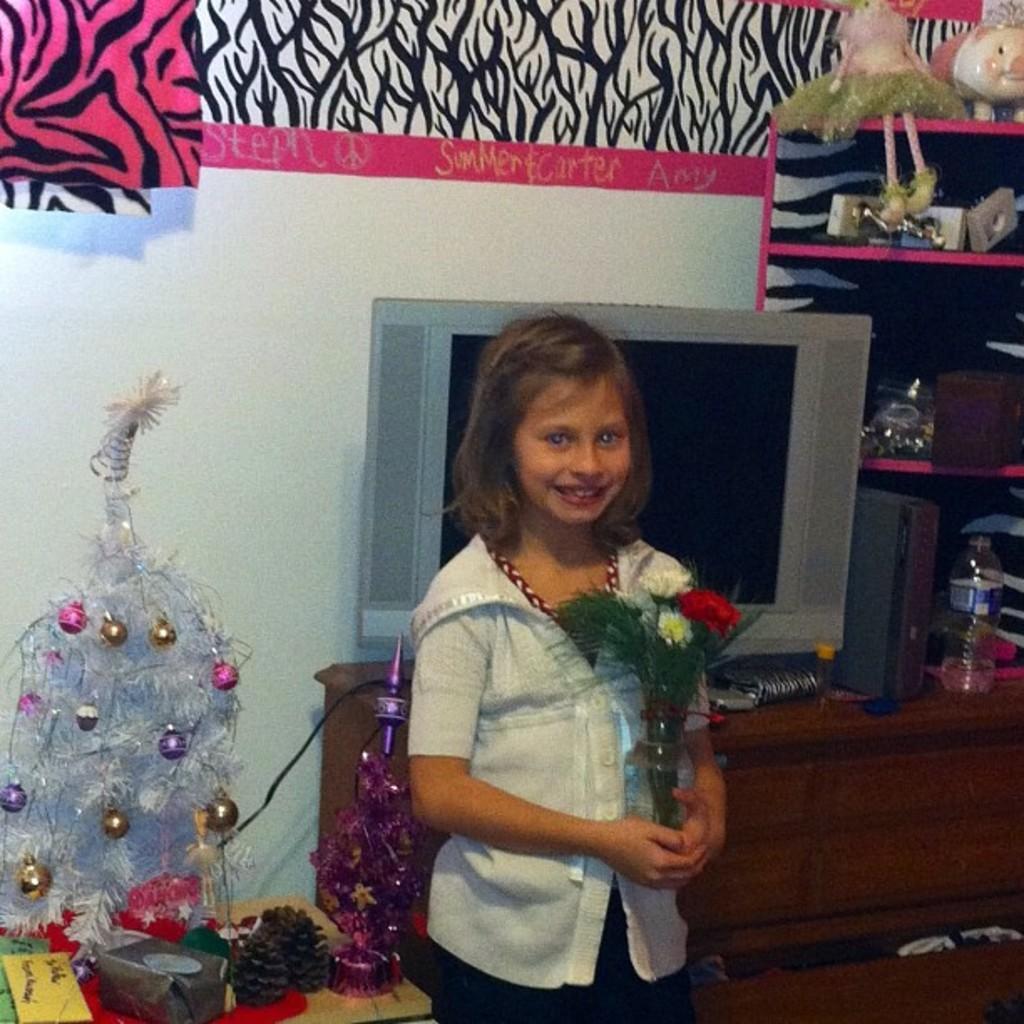In one or two sentences, can you explain what this image depicts? In this picture we can see a girl, she is holding a flower vase and in the background we can see a television, device, bottle, shelves, toys, cupboard, table, wall and some objects. 